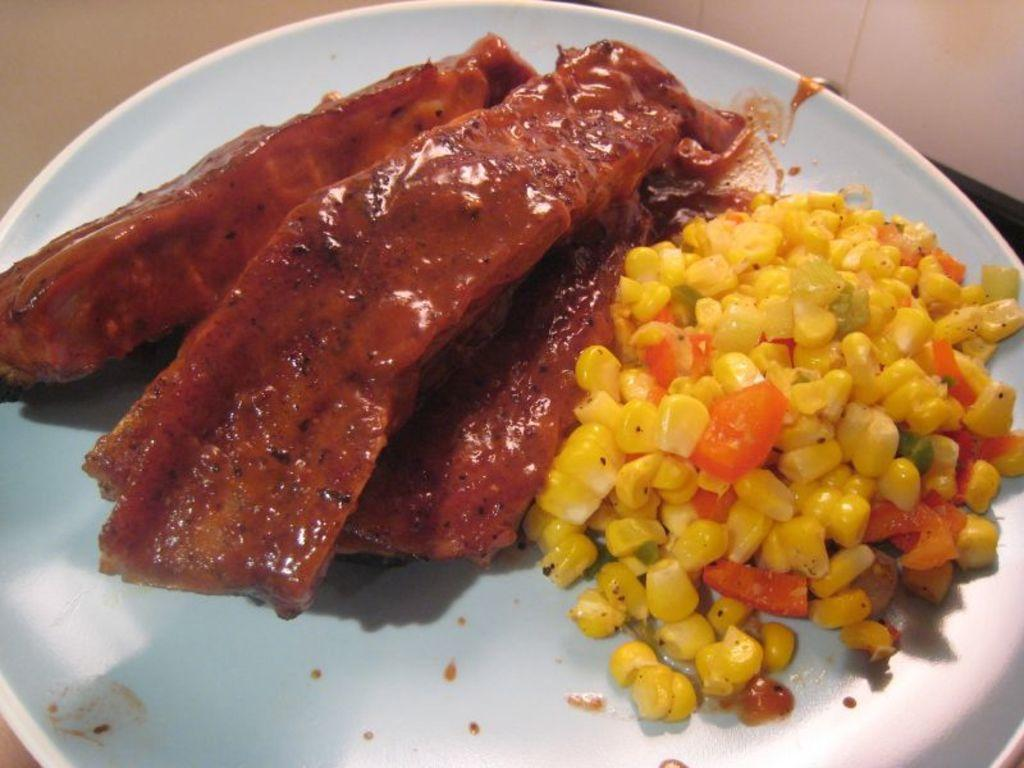What color is the plate in the image? The plate in the image is white. What type of food is on the plate? There are yellow color corn and other brown color food items on the plate. How many senses can be experienced while looking at the plate in the image? The image can only be experienced visually, so only one sense, sight, can be experienced while looking at the plate. 